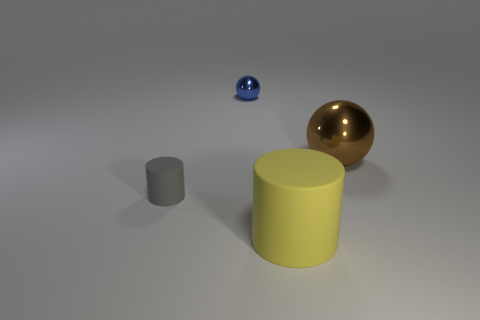Is the size of the gray matte cylinder the same as the sphere that is behind the big ball?
Make the answer very short. Yes. What number of gray cylinders have the same material as the large yellow thing?
Provide a short and direct response. 1. Do the brown shiny thing and the yellow matte object have the same size?
Give a very brief answer. Yes. Is there anything else of the same color as the small ball?
Keep it short and to the point. No. What shape is the object that is left of the big rubber thing and behind the tiny matte cylinder?
Keep it short and to the point. Sphere. There is a matte cylinder behind the large yellow rubber cylinder; what is its size?
Make the answer very short. Small. There is a big object that is on the right side of the rubber cylinder that is in front of the small gray matte cylinder; how many blue balls are on the right side of it?
Offer a terse response. 0. Are there any spheres in front of the tiny metal thing?
Offer a very short reply. Yes. How many other things are there of the same size as the blue sphere?
Give a very brief answer. 1. The object that is to the right of the small sphere and behind the large yellow matte cylinder is made of what material?
Keep it short and to the point. Metal. 